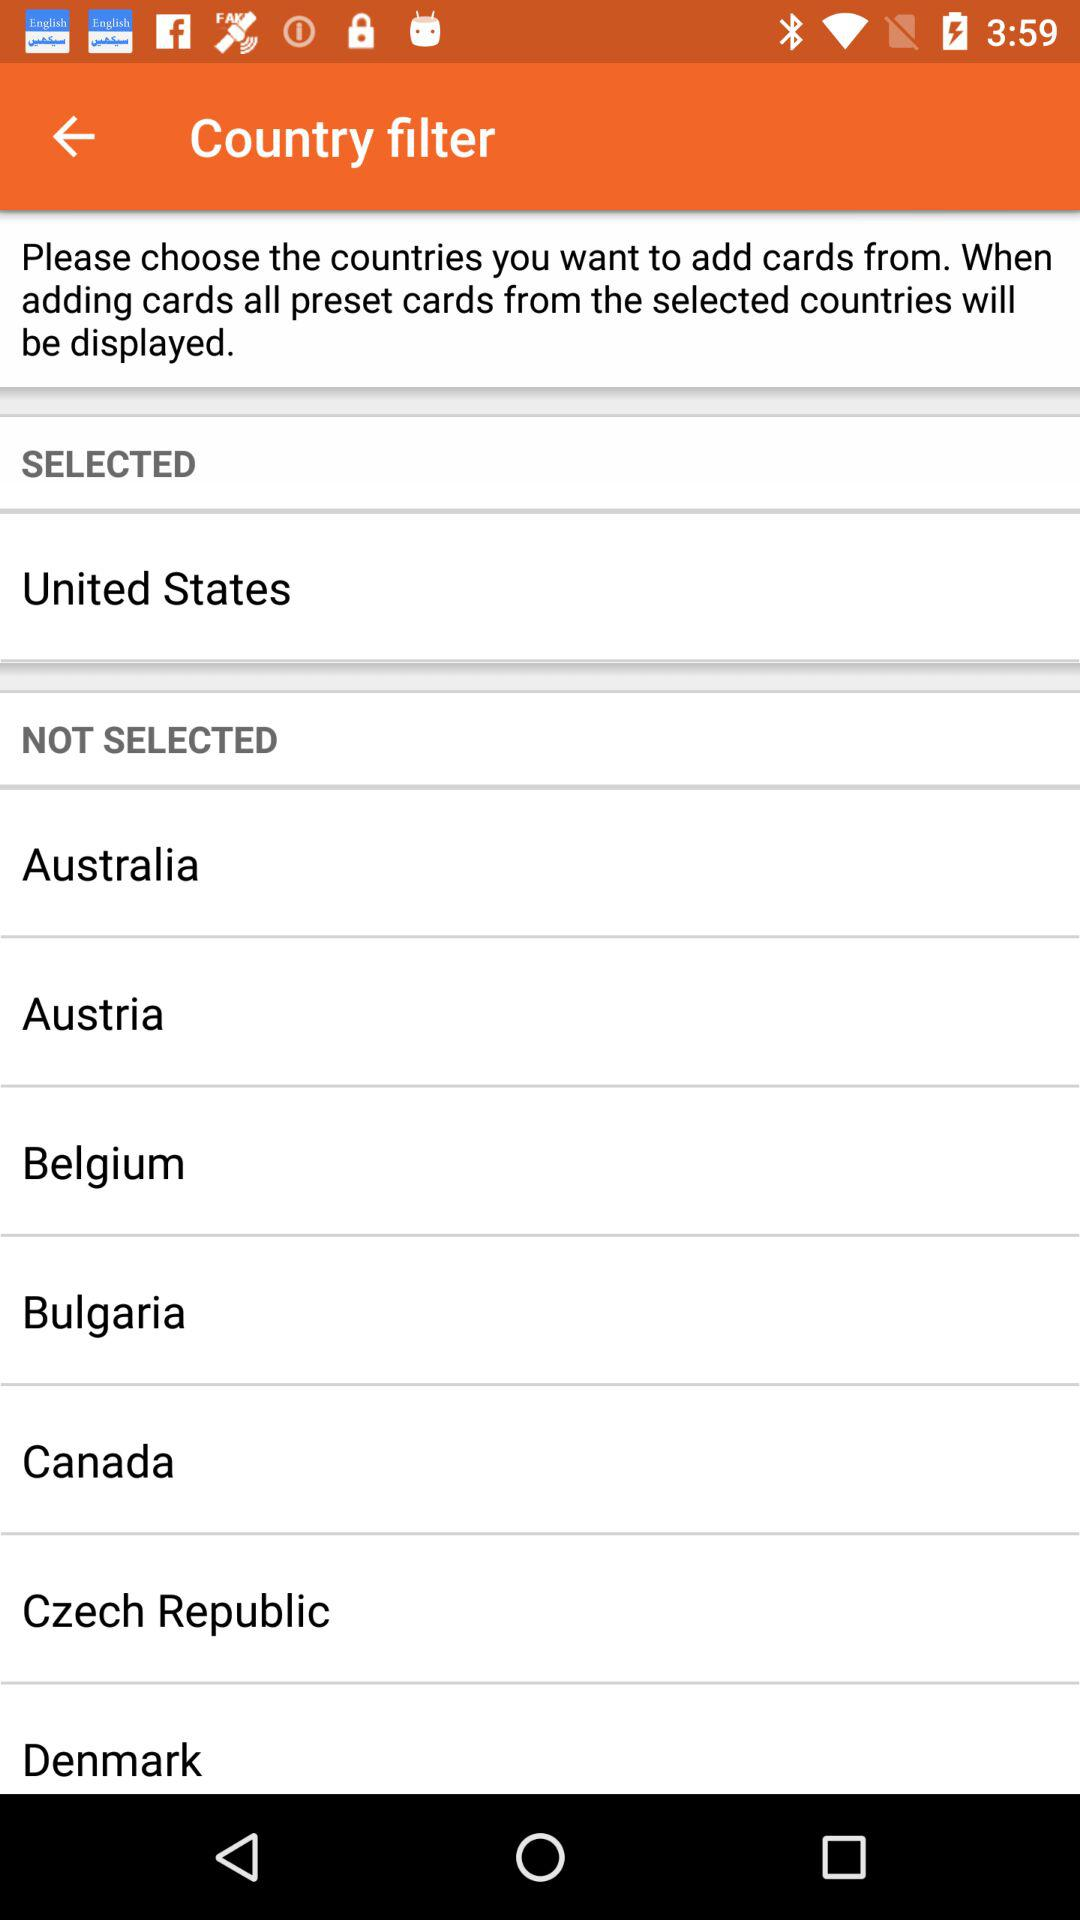How many countries are not selected?
Answer the question using a single word or phrase. 7 